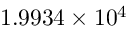<formula> <loc_0><loc_0><loc_500><loc_500>1 . 9 9 3 4 \times 1 0 ^ { 4 }</formula> 